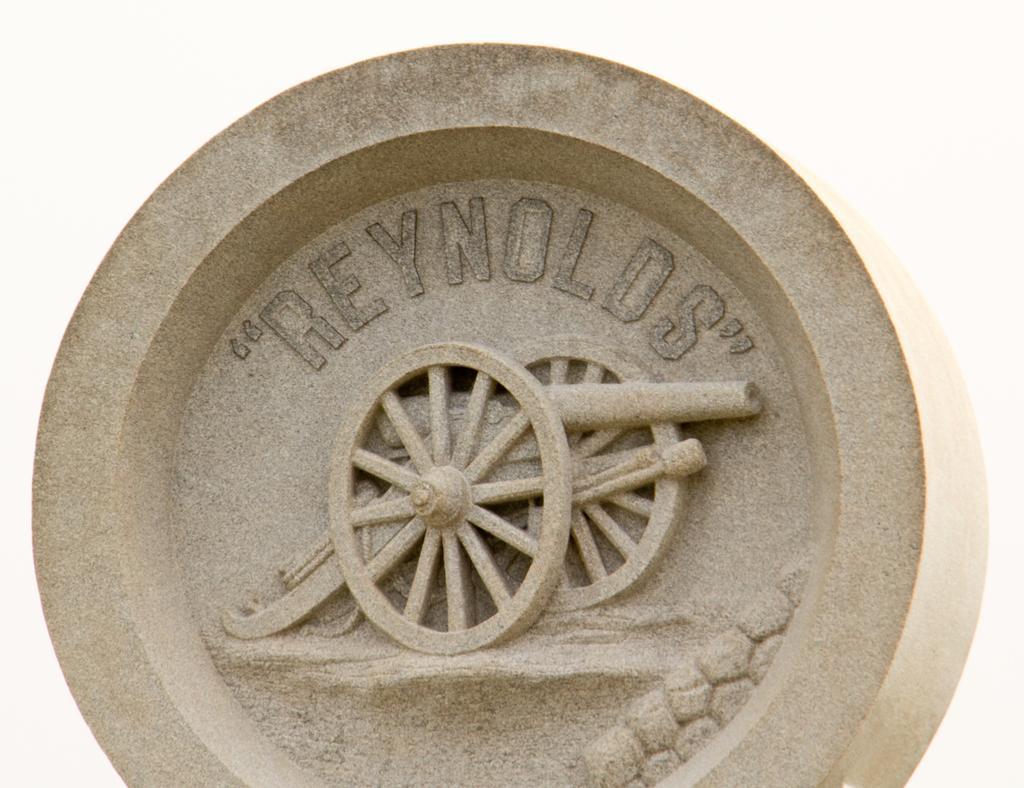Can you describe this image briefly? In the picture I can see a round shaped object which has something written on it. The background of the image is white in color. 